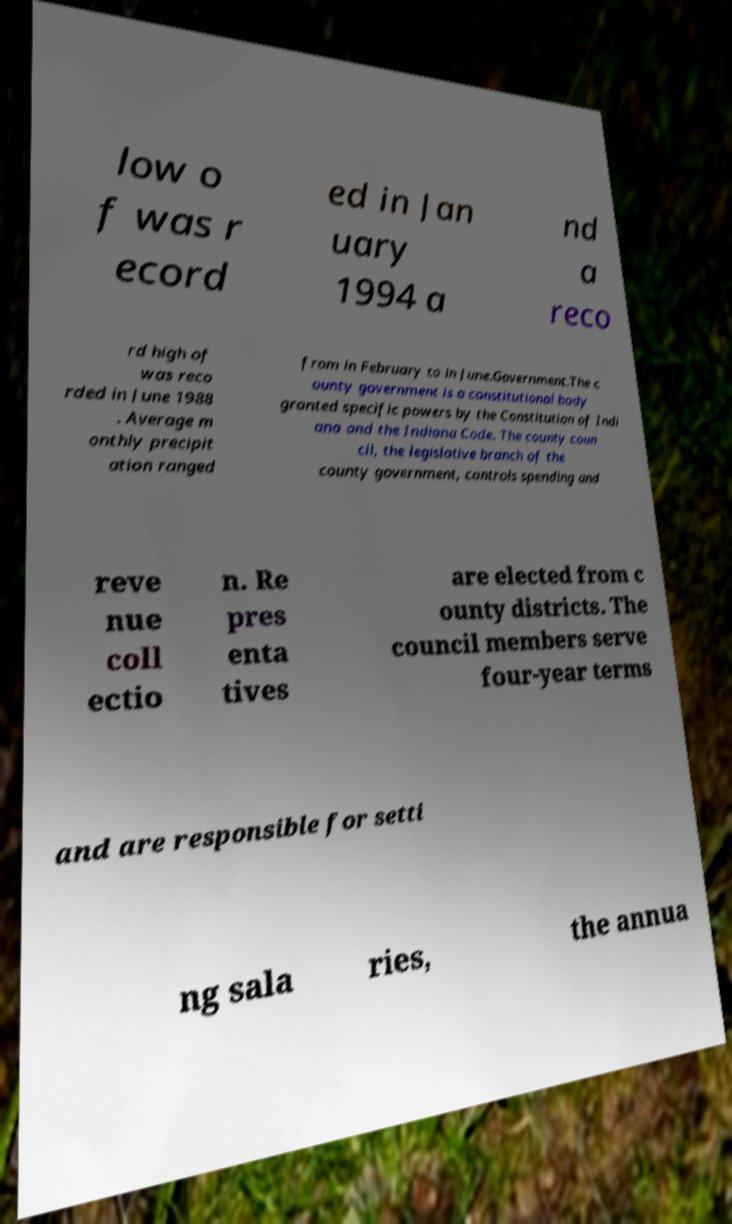Please identify and transcribe the text found in this image. low o f was r ecord ed in Jan uary 1994 a nd a reco rd high of was reco rded in June 1988 . Average m onthly precipit ation ranged from in February to in June.Government.The c ounty government is a constitutional body granted specific powers by the Constitution of Indi ana and the Indiana Code. The county coun cil, the legislative branch of the county government, controls spending and reve nue coll ectio n. Re pres enta tives are elected from c ounty districts. The council members serve four-year terms and are responsible for setti ng sala ries, the annua 